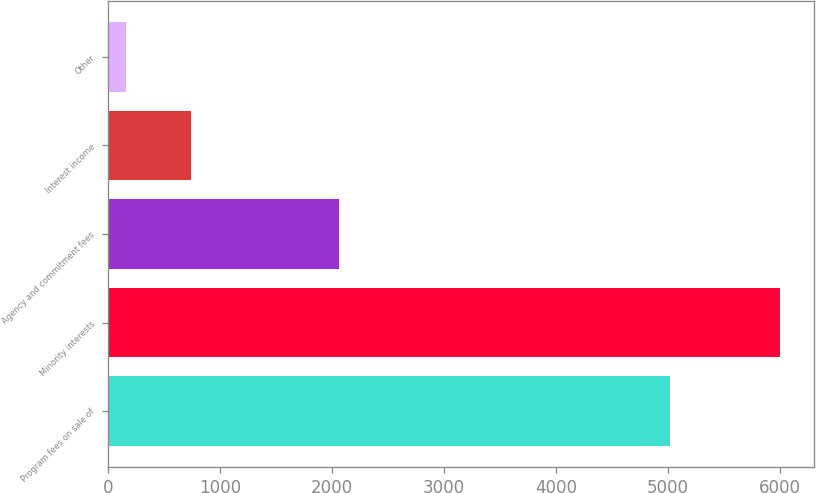Convert chart to OTSL. <chart><loc_0><loc_0><loc_500><loc_500><bar_chart><fcel>Program fees on sale of<fcel>Minority interests<fcel>Agency and commitment fees<fcel>Interest income<fcel>Other<nl><fcel>5018<fcel>6001<fcel>2057<fcel>738.7<fcel>154<nl></chart> 